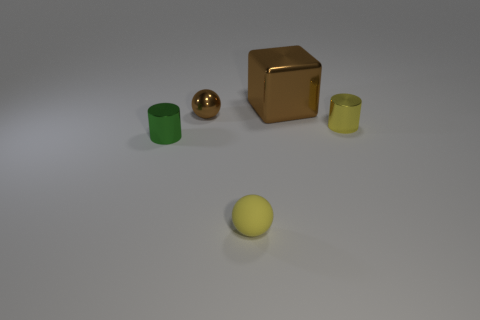There is a ball that is behind the matte object; does it have the same size as the thing in front of the green metallic cylinder?
Provide a short and direct response. Yes. The cylinder that is on the left side of the brown object that is to the left of the big shiny object is made of what material?
Ensure brevity in your answer.  Metal. What number of things are small cylinders left of the yellow metal thing or green objects?
Your response must be concise. 1. Is the number of tiny shiny balls that are in front of the brown shiny block the same as the number of tiny matte balls to the right of the small yellow metal object?
Keep it short and to the point. No. There is a small cylinder to the left of the small metal cylinder that is behind the metallic thing in front of the small yellow metal thing; what is it made of?
Offer a very short reply. Metal. There is a metal object that is to the left of the yellow cylinder and to the right of the yellow matte object; how big is it?
Your answer should be compact. Large. Is the shape of the small yellow metallic object the same as the green metal thing?
Your answer should be very brief. Yes. There is a green object that is made of the same material as the large brown thing; what shape is it?
Make the answer very short. Cylinder. How many tiny things are either green things or metallic objects?
Your response must be concise. 3. There is a tiny cylinder that is to the right of the brown cube; are there any metallic cylinders in front of it?
Offer a very short reply. Yes. 